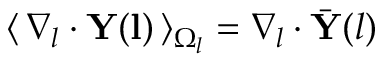Convert formula to latex. <formula><loc_0><loc_0><loc_500><loc_500>\langle \, \nabla _ { l } \cdot Y ( l ) \, \rangle _ { \Omega _ { l } } = \nabla _ { l } \cdot \bar { Y } ( l )</formula> 